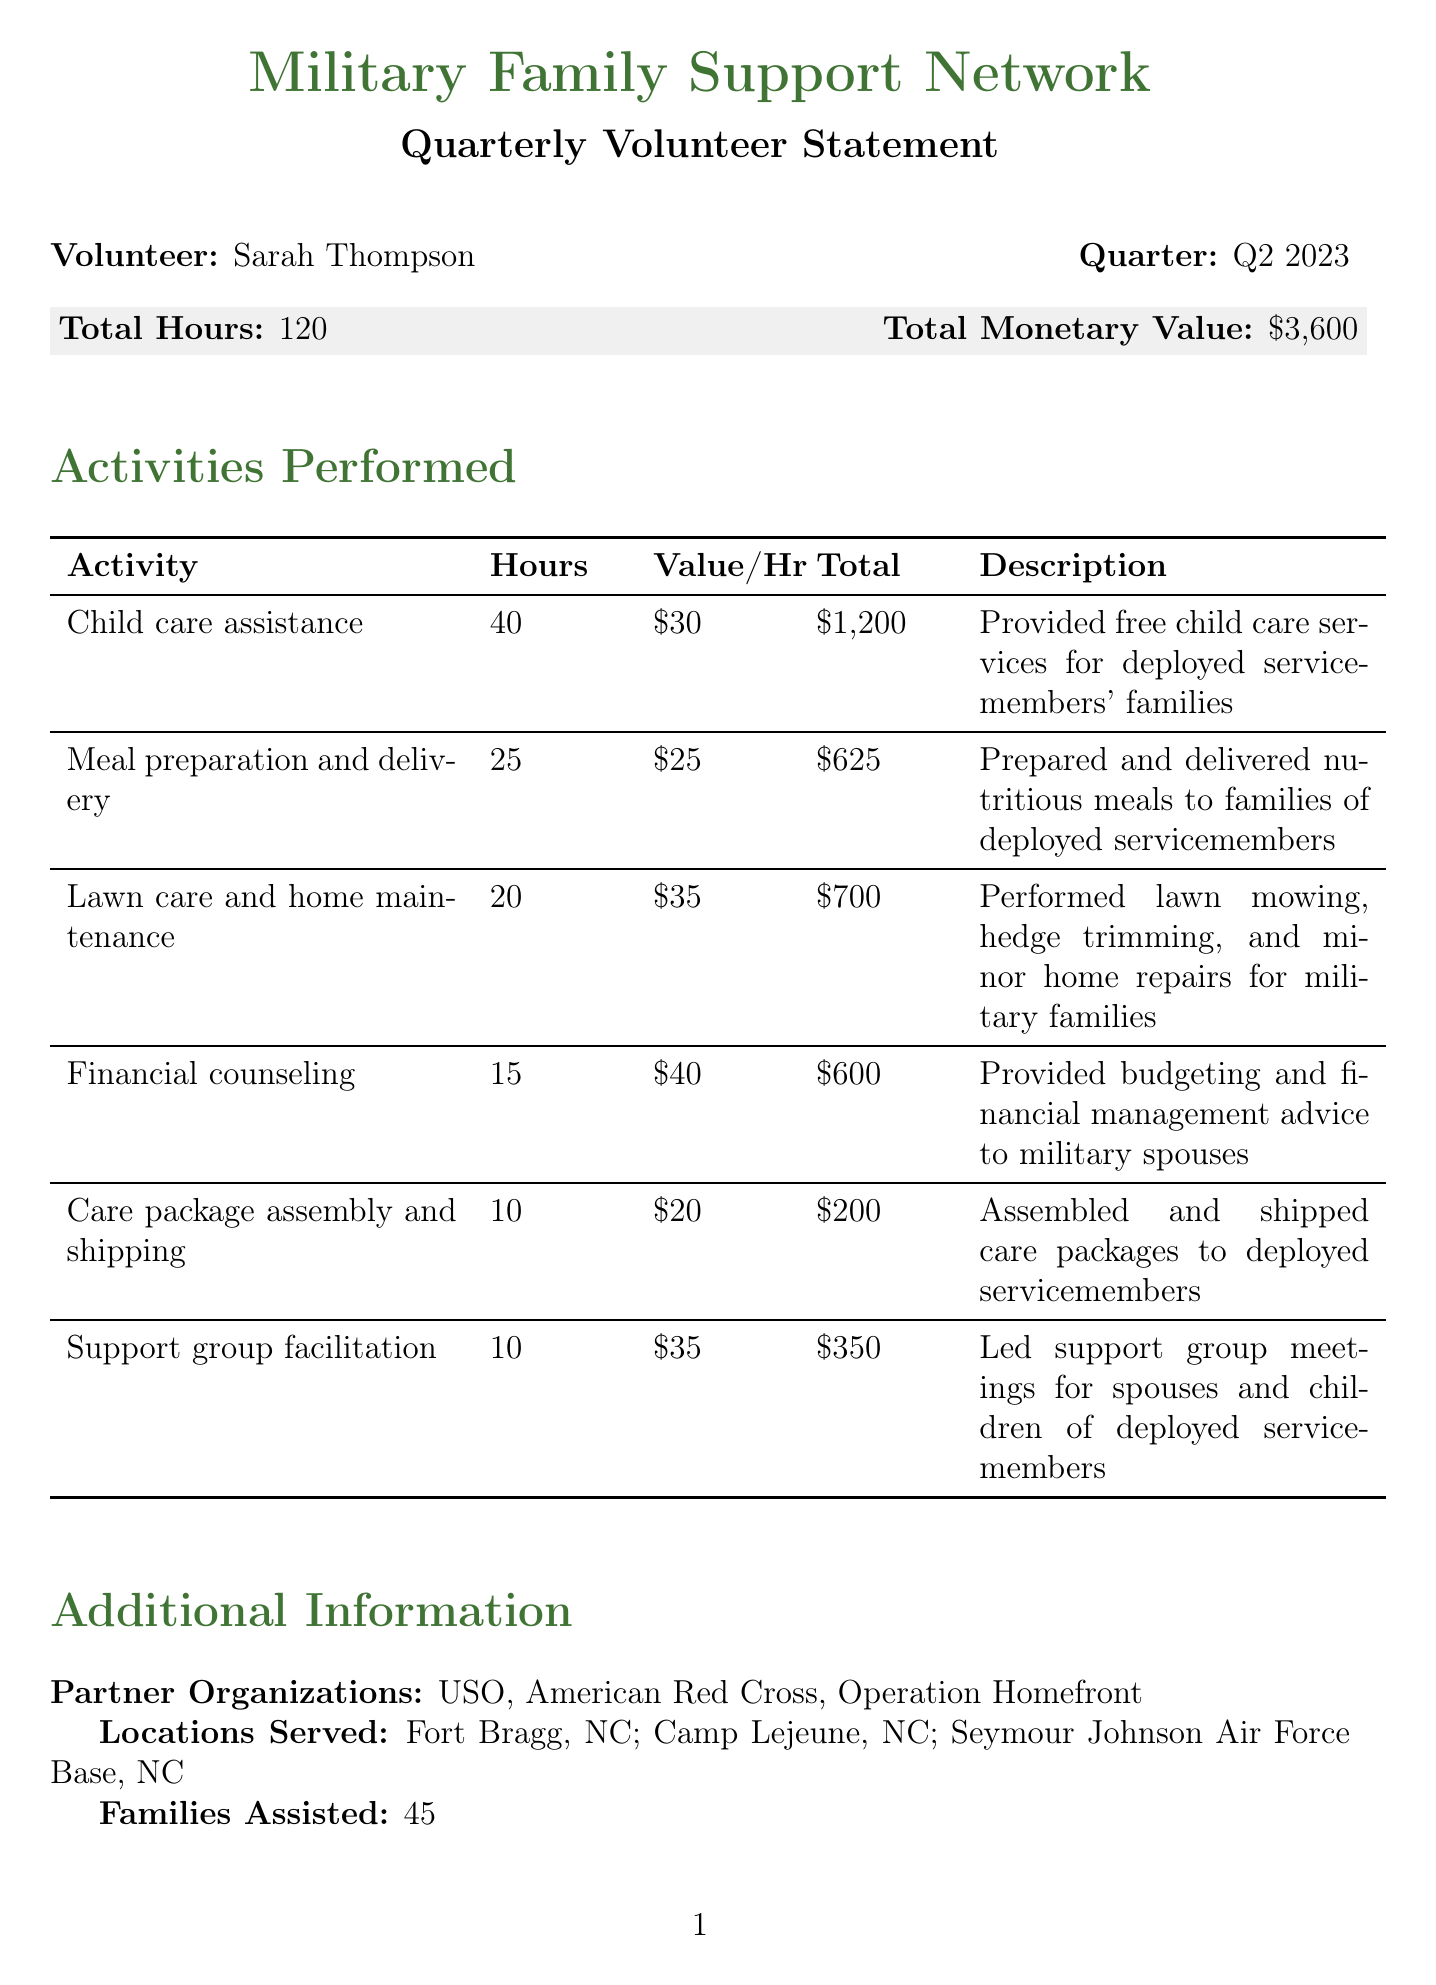What is the organization name? The organization name is provided at the top of the document.
Answer: Military Family Support Network Who is the volunteer? The volunteer's name is stated in the document with a bold label.
Answer: Sarah Thompson What quarter does this statement cover? The quarter for which the statement is generated is stated clearly.
Answer: Q2 2023 How many total hours did the volunteer contribute? Total hours contributed by the volunteer are mentioned in the summary section.
Answer: 120 What is the total monetary value of the volunteer hours? The total monetary value is distinctly specified in the document.
Answer: $3,600 Which activity had the highest hourly rate? This requires reasoning over the activities and their hourly values presented in the table.
Answer: Financial counseling How many families did the volunteer assist? The number of families assisted is mentioned in the additional information section.
Answer: 45 What type of services were provided for child care? The description for child care assistance outlines the specific service type.
Answer: Provided free child care services for deployed servicemembers' families Who provided the testimonial about the volunteer? The testimonial section quotes a specific individual acknowledging the volunteer's work.
Answer: Col. James Peterson, Family Readiness Officer 